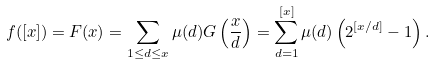<formula> <loc_0><loc_0><loc_500><loc_500>f ( [ x ] ) & = F ( x ) = \sum _ { 1 \leq d \leq x } \mu ( d ) G \left ( \frac { x } { d } \right ) = \sum _ { d = 1 } ^ { [ x ] } \mu ( d ) \left ( 2 ^ { [ x / d ] } - 1 \right ) .</formula> 